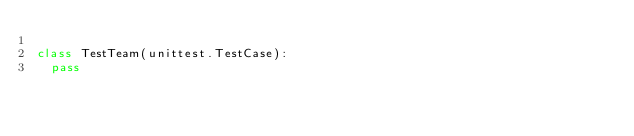<code> <loc_0><loc_0><loc_500><loc_500><_Python_>
class TestTeam(unittest.TestCase):
	pass
</code> 